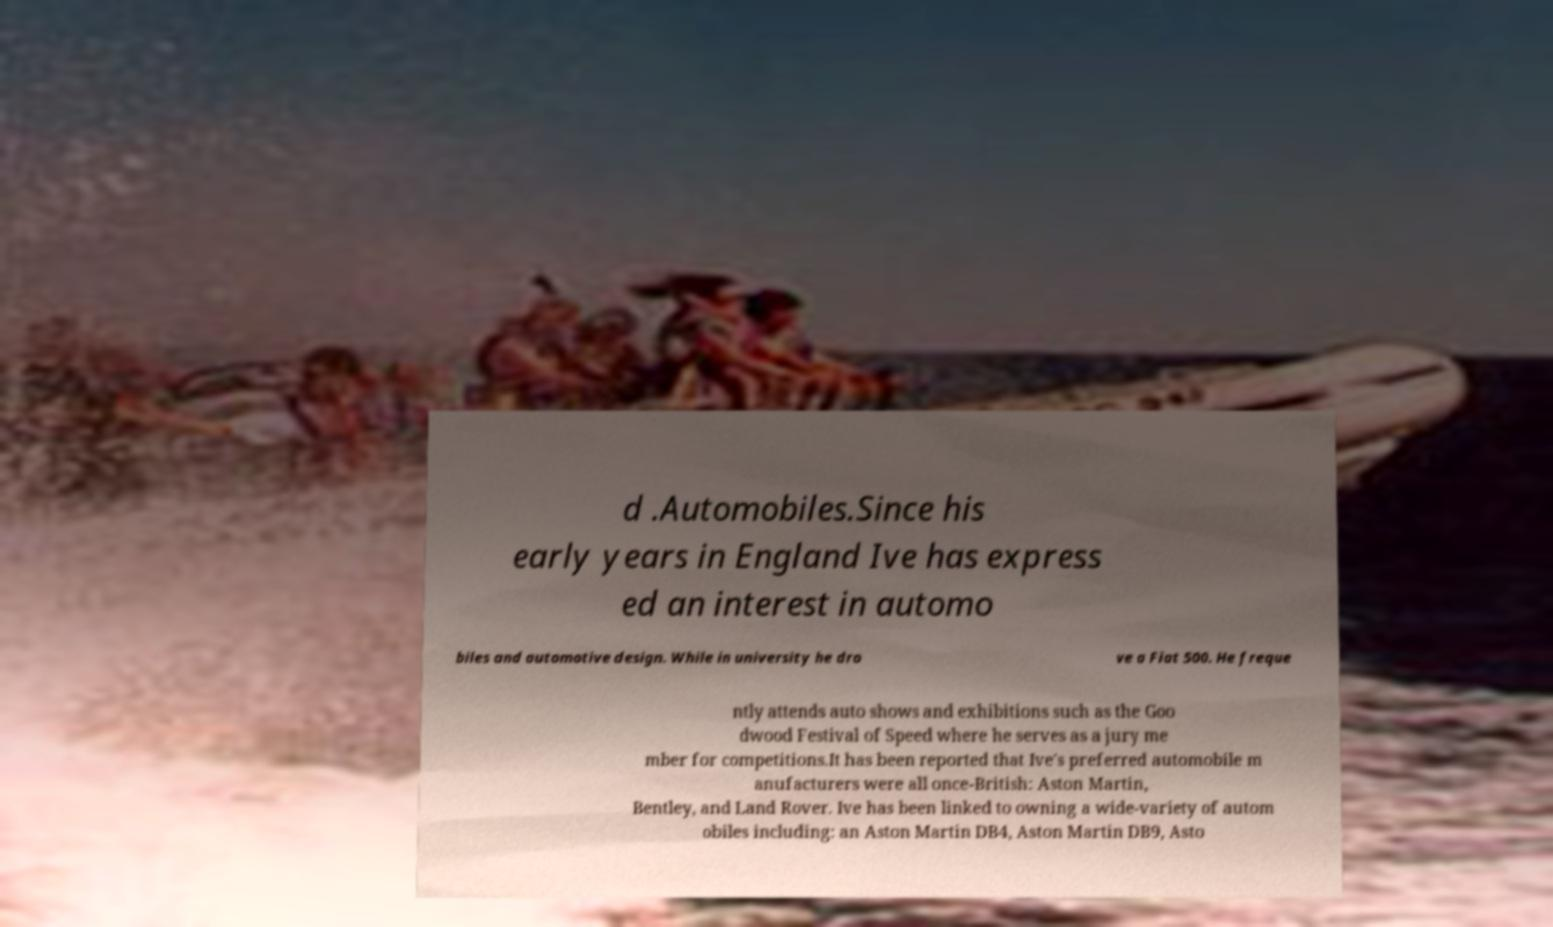For documentation purposes, I need the text within this image transcribed. Could you provide that? d .Automobiles.Since his early years in England Ive has express ed an interest in automo biles and automotive design. While in university he dro ve a Fiat 500. He freque ntly attends auto shows and exhibitions such as the Goo dwood Festival of Speed where he serves as a jury me mber for competitions.It has been reported that Ive's preferred automobile m anufacturers were all once-British: Aston Martin, Bentley, and Land Rover. Ive has been linked to owning a wide-variety of autom obiles including: an Aston Martin DB4, Aston Martin DB9, Asto 